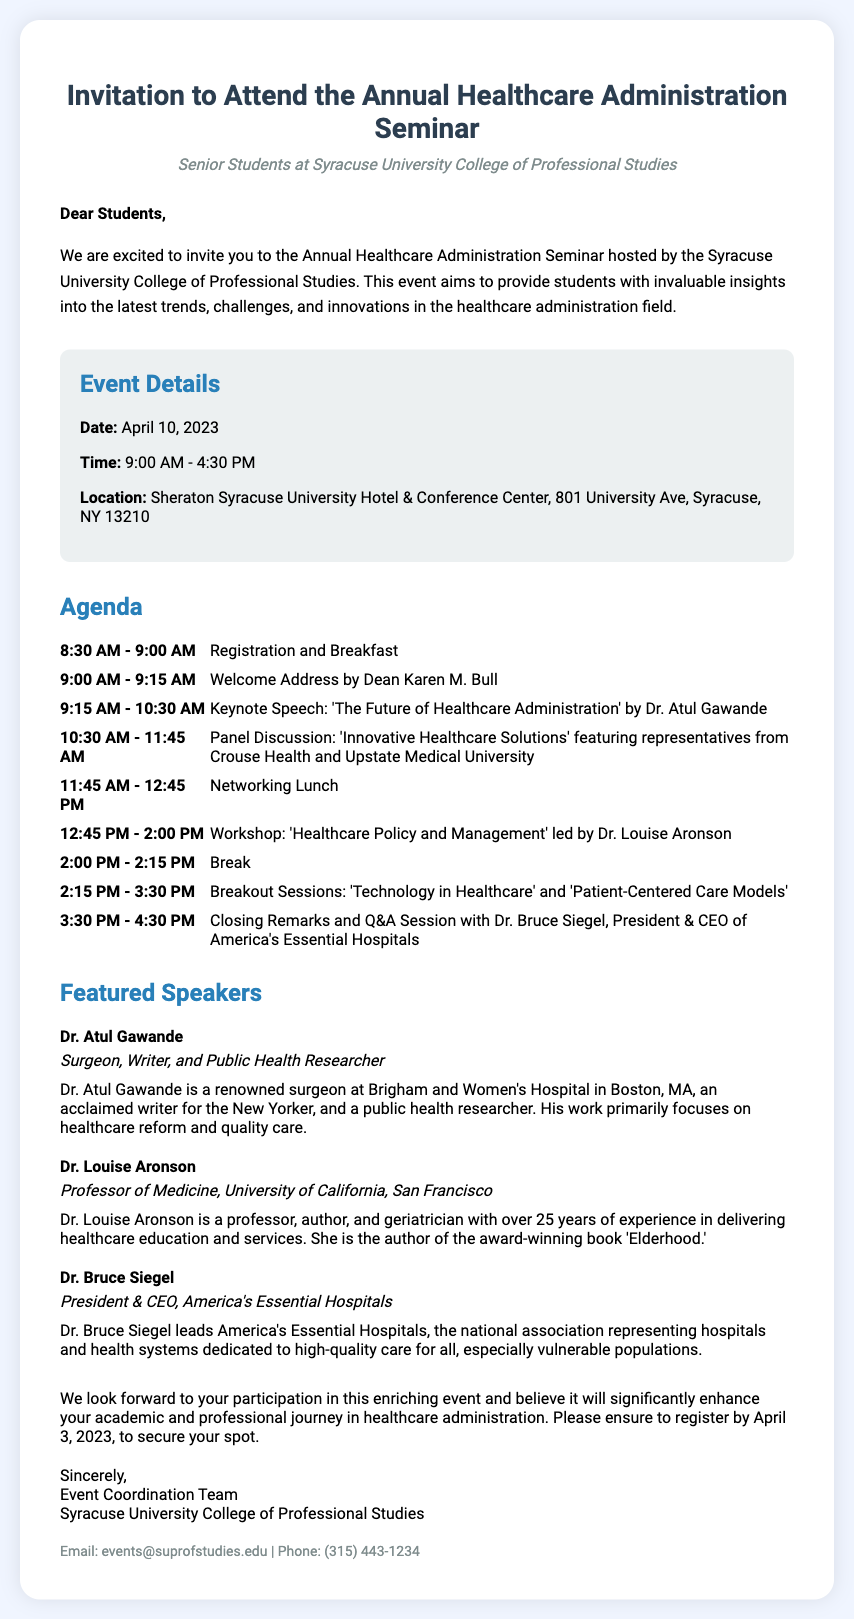what is the date of the seminar? The date of the seminar is mentioned clearly in the event details section of the document.
Answer: April 10, 2023 who is the keynote speaker? The keynote speaker is introduced in the agenda section, particularly during the keynote speech timing.
Answer: Dr. Atul Gawande where is the seminar located? The location of the seminar is specified in the event details section of the document.
Answer: Sheraton Syracuse University Hotel & Conference Center what time does registration start? The registration time is stated at the beginning of the agenda section.
Answer: 8:30 AM which speaker leads the workshop on healthcare policy? The workshop leader is listed in the agenda, providing their title and name as well.
Answer: Dr. Louise Aronson how long is the networking lunch? The duration of the networking lunch is defined in the agenda section.
Answer: 1 hour what is the final activity of the seminar? The last activity is described in the agenda section under the closing remarks.
Answer: Closing Remarks and Q&A Session with Dr. Bruce Siegel how many featured speakers are mentioned? The number of featured speakers can be counted in the speakers section of the document.
Answer: 3 